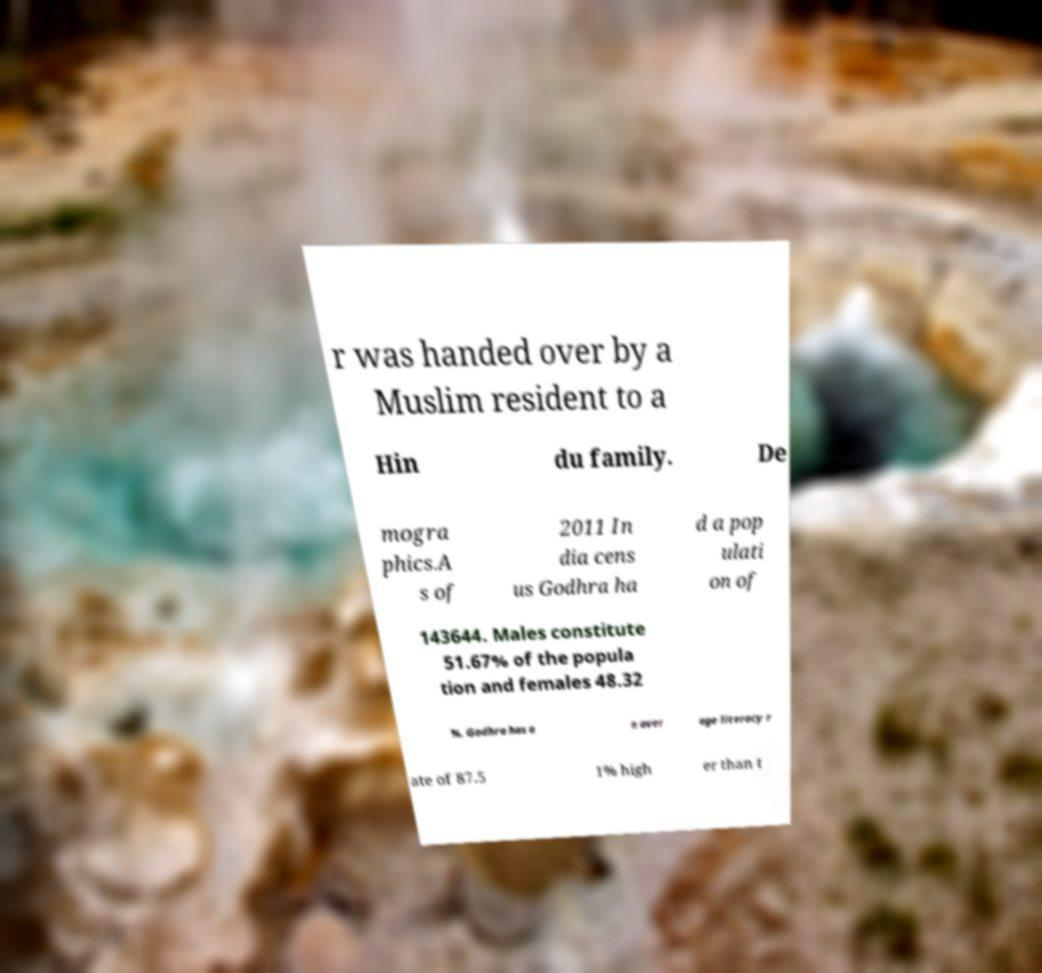What messages or text are displayed in this image? I need them in a readable, typed format. r was handed over by a Muslim resident to a Hin du family. De mogra phics.A s of 2011 In dia cens us Godhra ha d a pop ulati on of 143644. Males constitute 51.67% of the popula tion and females 48.32 %. Godhra has a n aver age literacy r ate of 87.5 1% high er than t 